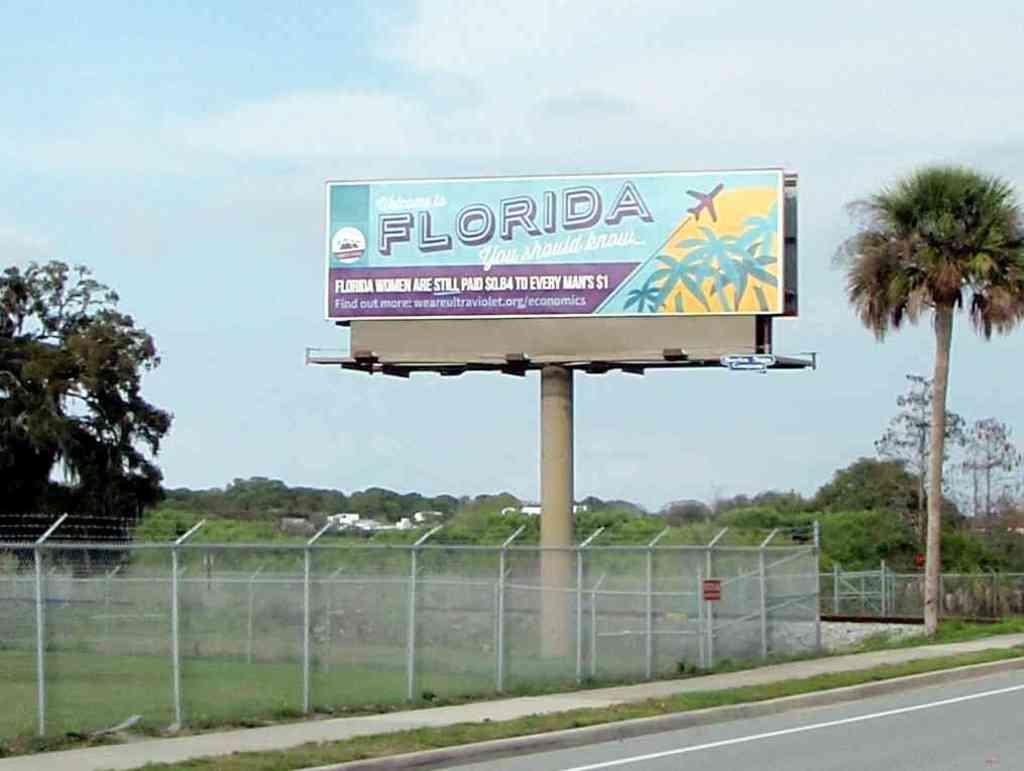<image>
Write a terse but informative summary of the picture. A sign that has Florida on it in big letters is on the side of the road. 